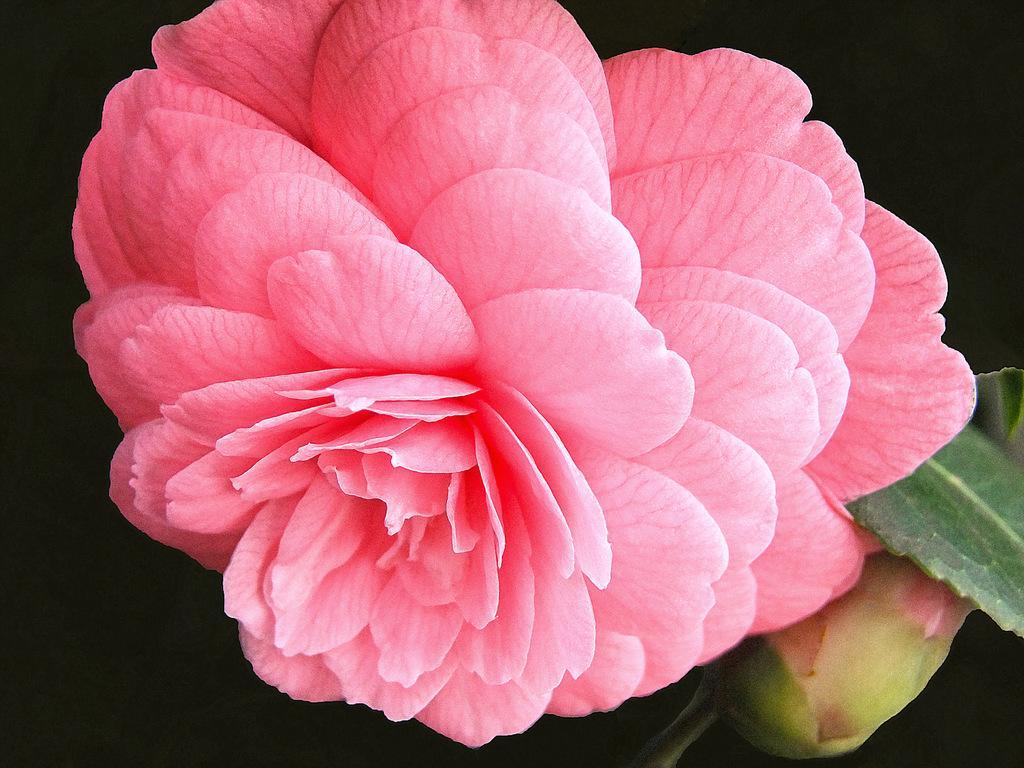How would you summarize this image in a sentence or two? In this image I can see a pink colour flower, a green bud and green leaves. I can also see black color in background. 